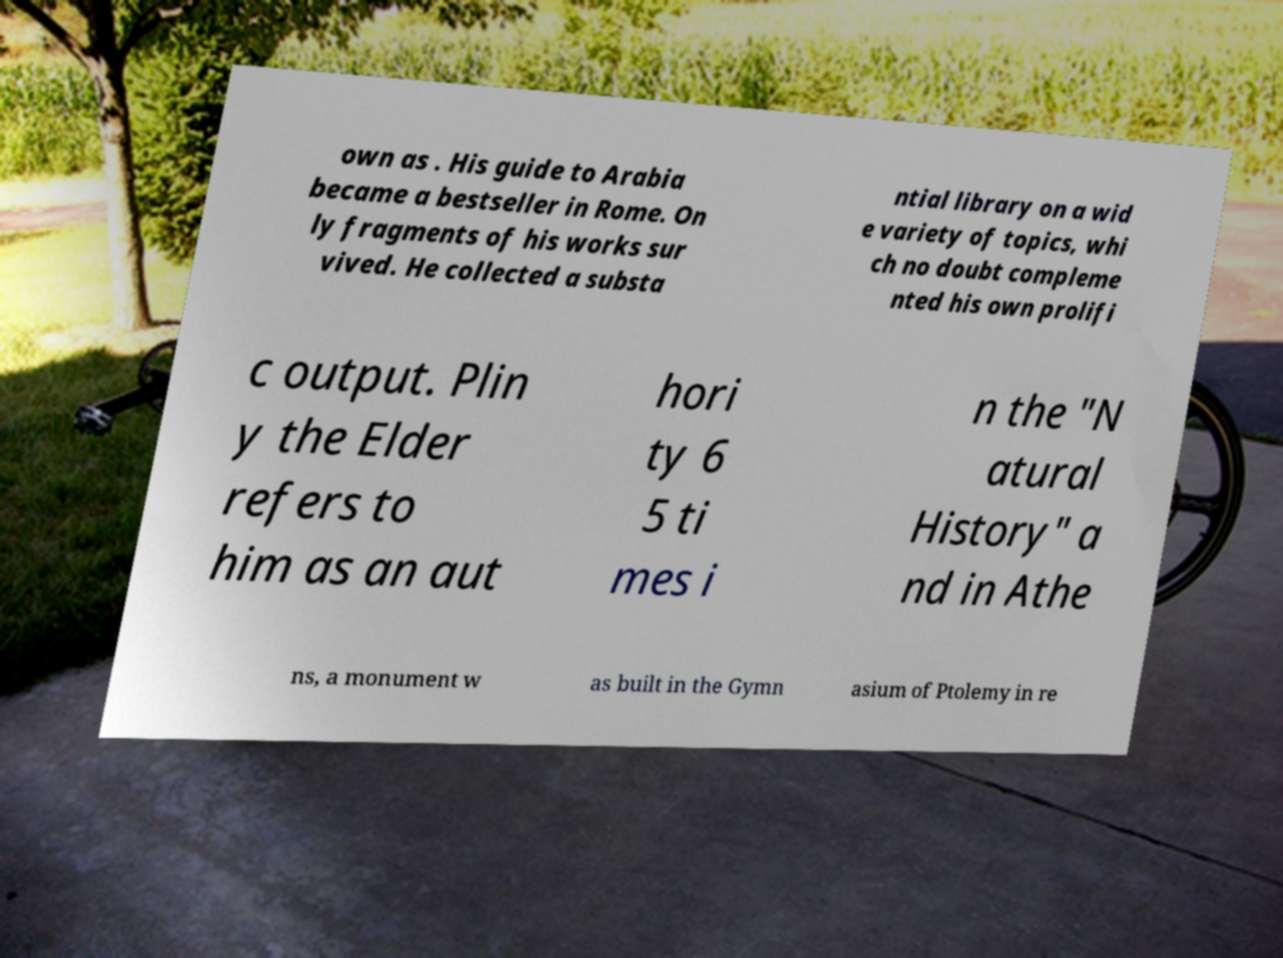Can you read and provide the text displayed in the image?This photo seems to have some interesting text. Can you extract and type it out for me? own as . His guide to Arabia became a bestseller in Rome. On ly fragments of his works sur vived. He collected a substa ntial library on a wid e variety of topics, whi ch no doubt compleme nted his own prolifi c output. Plin y the Elder refers to him as an aut hori ty 6 5 ti mes i n the "N atural History" a nd in Athe ns, a monument w as built in the Gymn asium of Ptolemy in re 